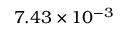<formula> <loc_0><loc_0><loc_500><loc_500>7 . 4 3 \times 1 0 ^ { - 3 }</formula> 